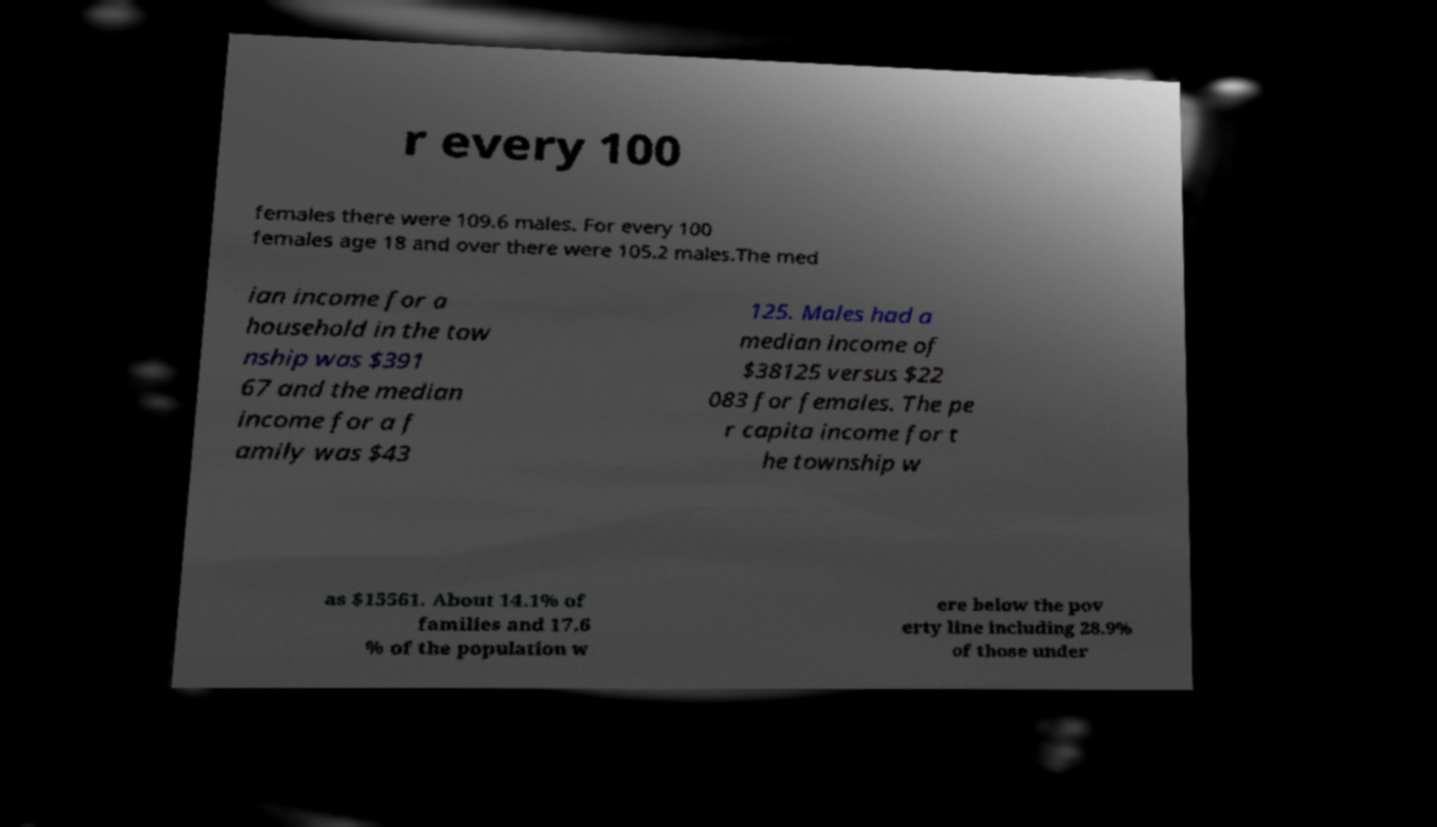For documentation purposes, I need the text within this image transcribed. Could you provide that? r every 100 females there were 109.6 males. For every 100 females age 18 and over there were 105.2 males.The med ian income for a household in the tow nship was $391 67 and the median income for a f amily was $43 125. Males had a median income of $38125 versus $22 083 for females. The pe r capita income for t he township w as $15561. About 14.1% of families and 17.6 % of the population w ere below the pov erty line including 28.9% of those under 